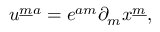<formula> <loc_0><loc_0><loc_500><loc_500>u ^ { { \underline { m } } a } = e ^ { a m } \partial _ { m } x ^ { \underline { m } } ,</formula> 